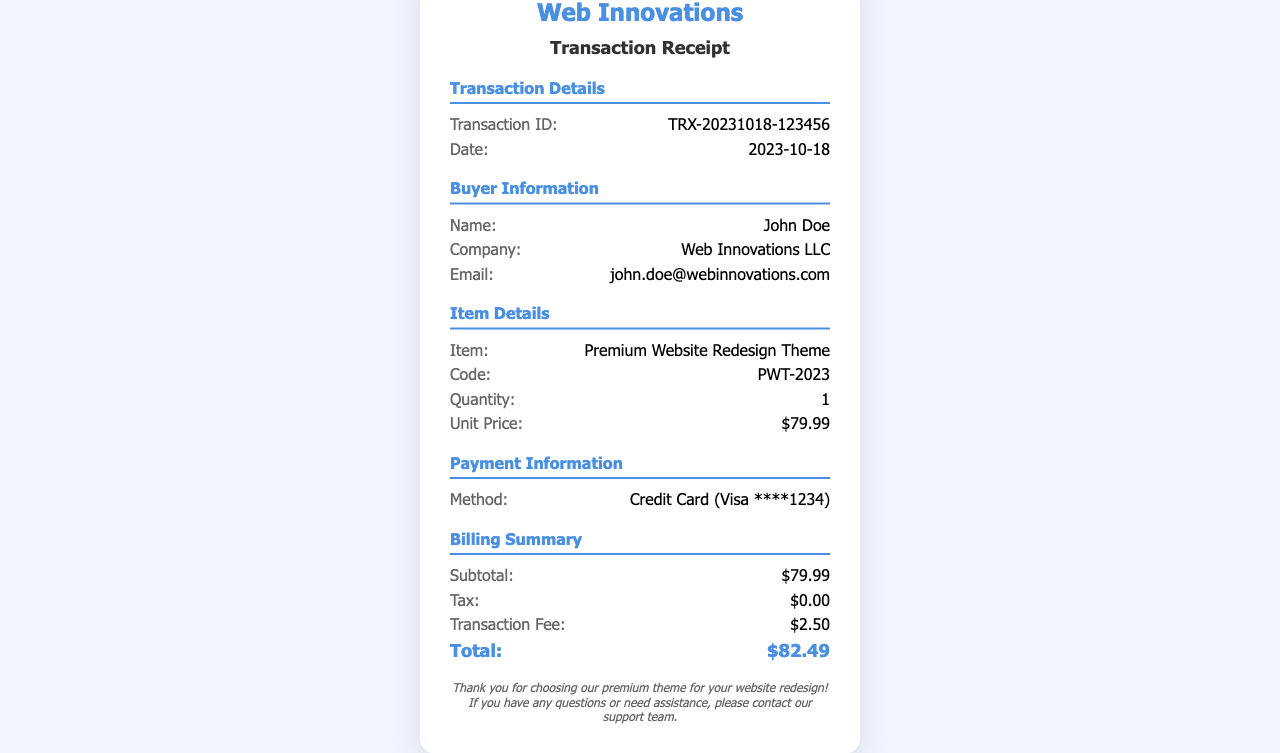What is the transaction ID? The transaction ID is displayed in the transaction details section of the document.
Answer: TRX-20231018-123456 When was the purchase made? The date of purchase is indicated in the transaction details section.
Answer: 2023-10-18 Who is the buyer? The buyer's name is provided under buyer information in the document.
Answer: John Doe What is the unit price of the item? The unit price is listed in the item details section.
Answer: $79.99 What is the total amount charged? The total amount is the sum of the subtotal, tax, and transaction fee, indicated in the billing summary.
Answer: $82.49 What was the payment method used? The payment method is noted in the payment information section of the receipt.
Answer: Credit Card (Visa ****1234) How much was the transaction fee? The transaction fee is part of the billing summary located in the document.
Answer: $2.50 What is the name of the purchased item? The name of the item can be found in the item details section of the document.
Answer: Premium Website Redesign Theme What company is listed under buyer information? The buyer's company is specified in the buyer information section.
Answer: Web Innovations LLC 